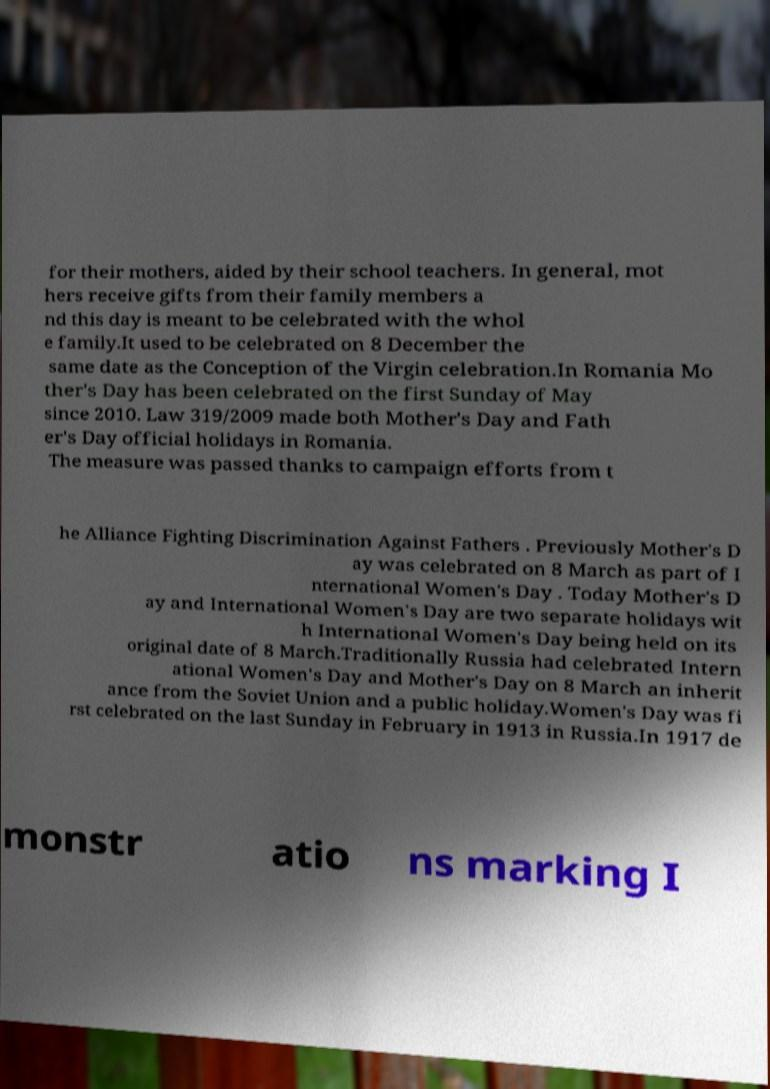Could you assist in decoding the text presented in this image and type it out clearly? for their mothers, aided by their school teachers. In general, mot hers receive gifts from their family members a nd this day is meant to be celebrated with the whol e family.It used to be celebrated on 8 December the same date as the Conception of the Virgin celebration.In Romania Mo ther's Day has been celebrated on the first Sunday of May since 2010. Law 319/2009 made both Mother's Day and Fath er's Day official holidays in Romania. The measure was passed thanks to campaign efforts from t he Alliance Fighting Discrimination Against Fathers . Previously Mother's D ay was celebrated on 8 March as part of I nternational Women's Day . Today Mother's D ay and International Women's Day are two separate holidays wit h International Women's Day being held on its original date of 8 March.Traditionally Russia had celebrated Intern ational Women's Day and Mother's Day on 8 March an inherit ance from the Soviet Union and a public holiday.Women's Day was fi rst celebrated on the last Sunday in February in 1913 in Russia.In 1917 de monstr atio ns marking I 